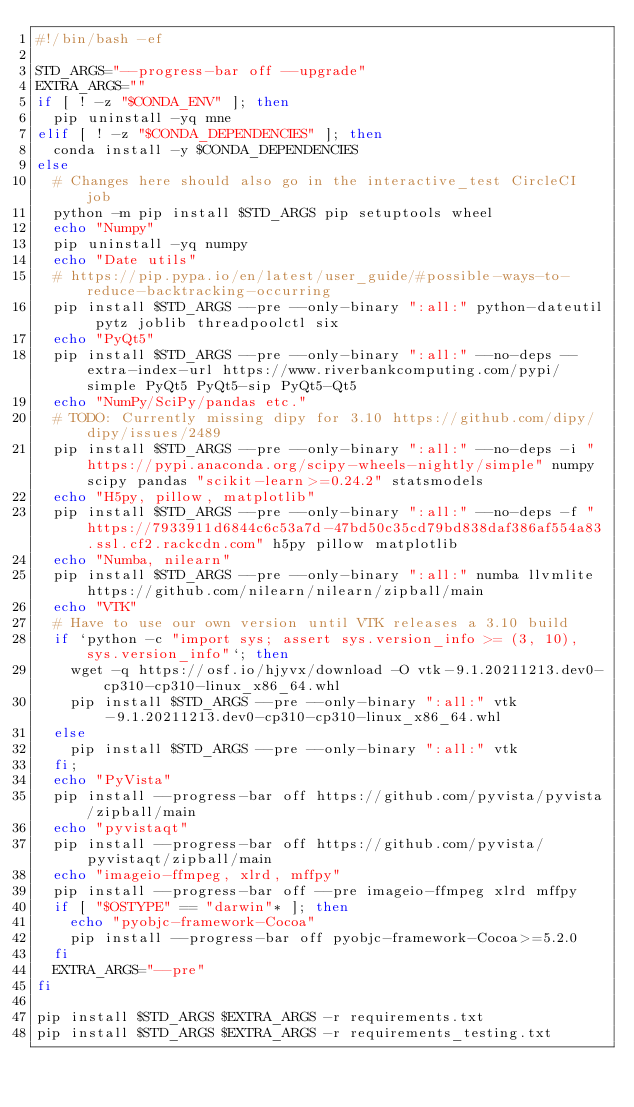Convert code to text. <code><loc_0><loc_0><loc_500><loc_500><_Bash_>#!/bin/bash -ef

STD_ARGS="--progress-bar off --upgrade"
EXTRA_ARGS=""
if [ ! -z "$CONDA_ENV" ]; then
	pip uninstall -yq mne
elif [ ! -z "$CONDA_DEPENDENCIES" ]; then
	conda install -y $CONDA_DEPENDENCIES
else
	# Changes here should also go in the interactive_test CircleCI job
	python -m pip install $STD_ARGS pip setuptools wheel
	echo "Numpy"
	pip uninstall -yq numpy
	echo "Date utils"
	# https://pip.pypa.io/en/latest/user_guide/#possible-ways-to-reduce-backtracking-occurring
	pip install $STD_ARGS --pre --only-binary ":all:" python-dateutil pytz joblib threadpoolctl six
	echo "PyQt5"
	pip install $STD_ARGS --pre --only-binary ":all:" --no-deps --extra-index-url https://www.riverbankcomputing.com/pypi/simple PyQt5 PyQt5-sip PyQt5-Qt5
	echo "NumPy/SciPy/pandas etc."
	# TODO: Currently missing dipy for 3.10 https://github.com/dipy/dipy/issues/2489
	pip install $STD_ARGS --pre --only-binary ":all:" --no-deps -i "https://pypi.anaconda.org/scipy-wheels-nightly/simple" numpy scipy pandas "scikit-learn>=0.24.2" statsmodels
	echo "H5py, pillow, matplotlib"
	pip install $STD_ARGS --pre --only-binary ":all:" --no-deps -f "https://7933911d6844c6c53a7d-47bd50c35cd79bd838daf386af554a83.ssl.cf2.rackcdn.com" h5py pillow matplotlib
	echo "Numba, nilearn"
	pip install $STD_ARGS --pre --only-binary ":all:" numba llvmlite https://github.com/nilearn/nilearn/zipball/main
	echo "VTK"
	# Have to use our own version until VTK releases a 3.10 build
	if `python -c "import sys; assert sys.version_info >= (3, 10), sys.version_info"`; then
		wget -q https://osf.io/hjyvx/download -O vtk-9.1.20211213.dev0-cp310-cp310-linux_x86_64.whl
		pip install $STD_ARGS --pre --only-binary ":all:" vtk-9.1.20211213.dev0-cp310-cp310-linux_x86_64.whl
	else
		pip install $STD_ARGS --pre --only-binary ":all:" vtk
	fi;
	echo "PyVista"
	pip install --progress-bar off https://github.com/pyvista/pyvista/zipball/main
	echo "pyvistaqt"
	pip install --progress-bar off https://github.com/pyvista/pyvistaqt/zipball/main
	echo "imageio-ffmpeg, xlrd, mffpy"
	pip install --progress-bar off --pre imageio-ffmpeg xlrd mffpy
	if [ "$OSTYPE" == "darwin"* ]; then
	  echo "pyobjc-framework-Cocoa"
	  pip install --progress-bar off pyobjc-framework-Cocoa>=5.2.0
	fi
	EXTRA_ARGS="--pre"
fi

pip install $STD_ARGS $EXTRA_ARGS -r requirements.txt
pip install $STD_ARGS $EXTRA_ARGS -r requirements_testing.txt
</code> 